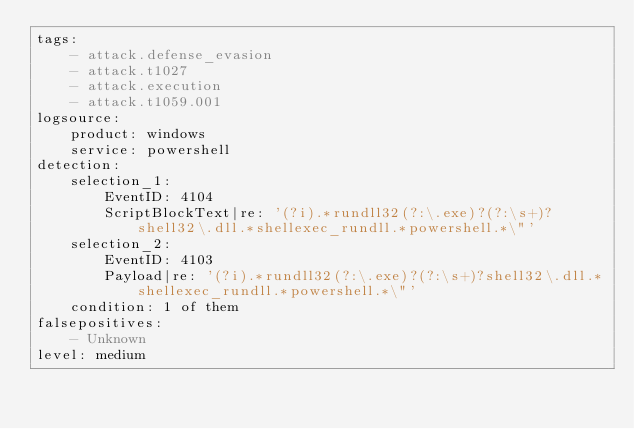<code> <loc_0><loc_0><loc_500><loc_500><_YAML_>tags:
    - attack.defense_evasion
    - attack.t1027
    - attack.execution
    - attack.t1059.001
logsource:
    product: windows
    service: powershell
detection:
    selection_1:
        EventID: 4104
        ScriptBlockText|re: '(?i).*rundll32(?:\.exe)?(?:\s+)?shell32\.dll.*shellexec_rundll.*powershell.*\"'
    selection_2:
        EventID: 4103
        Payload|re: '(?i).*rundll32(?:\.exe)?(?:\s+)?shell32\.dll.*shellexec_rundll.*powershell.*\"'
    condition: 1 of them
falsepositives:
    - Unknown
level: medium
</code> 